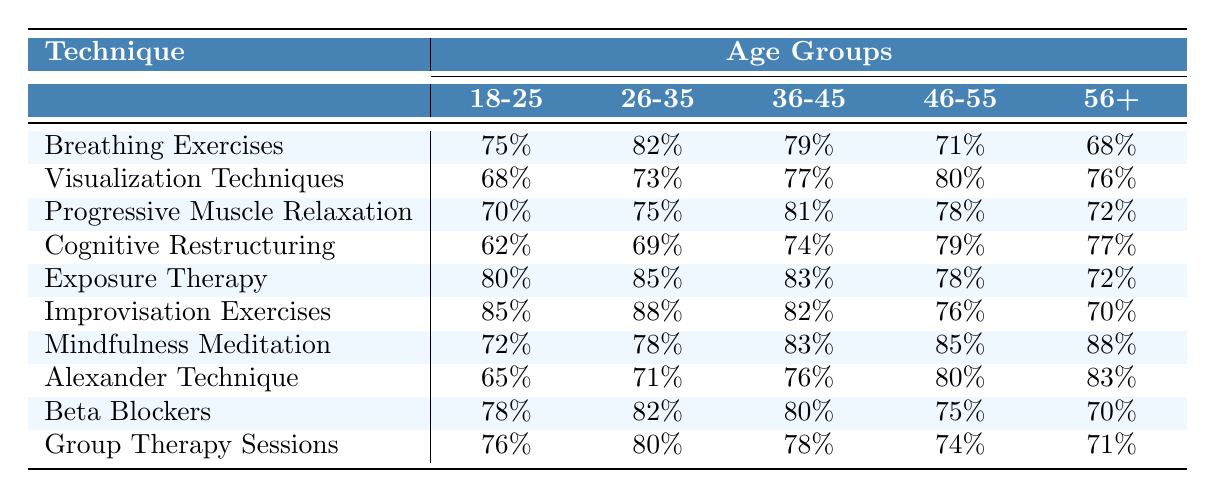What technique had the highest success rate for the age group 18-25? Looking at the table, I check the success rates for the age group 18-25. The highest percentage is for Improvisation Exercises at 85%.
Answer: Improvisation Exercises What technique had the lowest success rate in the 56+ age group? I examine the success rates for the 56+ age group and find that Group Therapy Sessions has the lowest rate at 71%.
Answer: Group Therapy Sessions What is the average success rate for Visualization Techniques across all age groups? I add the success rates for Visualization Techniques: 68 + 73 + 77 + 80 + 76 = 374. Then, I divide by 5 (the number of age groups) to get 374/5 = 74.8.
Answer: 74.8 Which technique had the highest success rate among individuals aged 36-45? I look at the 36-45 column and compare the values: Breathing Exercises (79), Visualization Techniques (77), Progressive Muscle Relaxation (81), Cognitive Restructuring (74), Exposure Therapy (83), Improvisation Exercises (82), Mindfulness Meditation (83), Alexander Technique (76), Beta Blockers (80), Group Therapy Sessions (78). Exposure Therapy ties with Mindfulness Meditation for the highest success rate at 83%.
Answer: Exposure Therapy and Mindfulness Meditation Is Cognitive Restructuring more effective than Progressive Muscle Relaxation for the 46-55 age group? I compare the rates: Cognitive Restructuring is at 79% and Progressive Muscle Relaxation is at 78%. Since 79% is greater than 78%, it confirms that Cognitive Restructuring is more effective.
Answer: Yes What is the difference in the success rate of Breathing Exercises between the age groups 18-25 and 56+? I find the success rates for Breathing Exercises: 18-25 is 75% and 56+ is 68%. The difference is 75 - 68 = 7%.
Answer: 7% Which age group showed the most improvement in success rates for Mindfulness Meditation compared to the lowest group? I examine the table examining Mindfulness Meditation: 72%, 78%, 83%, 85%, and 88%. The lowest is 72% (18-25) and the highest is 88% (56+), showing an improvement of 88 - 72 = 16%.
Answer: 16% What technique is consistently effective across age groups based on the table? I analyze the data to see which technique has relatively high success rates across all age groups. Improvisation Exercises and Mindfulness Meditation both have the highest scores and consistent performance across the board.
Answer: Improvisation Exercises and Mindfulness Meditation Among all techniques, which one had the lowest average success rate? I calculate the average rates for each technique: Breathing Exercises (74%), Visualization Techniques (74.4%), Progressive Muscle Relaxation (75.2%), Cognitive Restructuring (72.2%), Exposure Therapy (77.6%), Improvisation Exercises (78.2%), Mindfulness Meditation (80.2%), Alexander Technique (75%), Beta Blockers (75.6%), Group Therapy Sessions (76.2%). The lowest average is for Cognitive Restructuring at 72.2%.
Answer: Cognitive Restructuring 